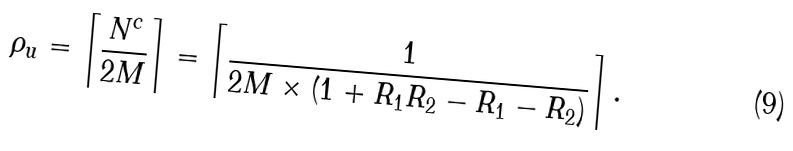Convert formula to latex. <formula><loc_0><loc_0><loc_500><loc_500>\rho _ { u } = \left \lceil \frac { N ^ { c } } { 2 M } \right \rceil = \left \lceil \frac { 1 } { 2 M \times ( 1 + R _ { 1 } R _ { 2 } - R _ { 1 } - R _ { 2 } ) } \right \rceil .</formula> 